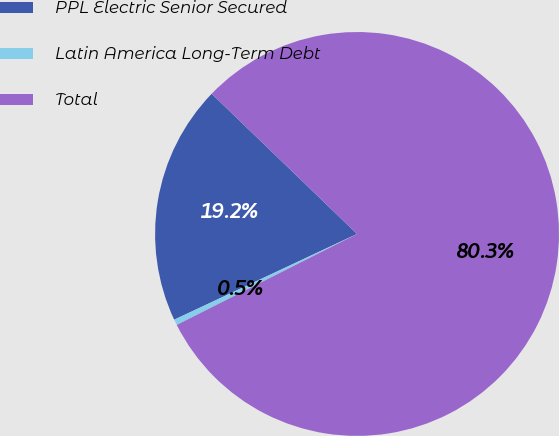Convert chart to OTSL. <chart><loc_0><loc_0><loc_500><loc_500><pie_chart><fcel>PPL Electric Senior Secured<fcel>Latin America Long-Term Debt<fcel>Total<nl><fcel>19.19%<fcel>0.46%<fcel>80.35%<nl></chart> 